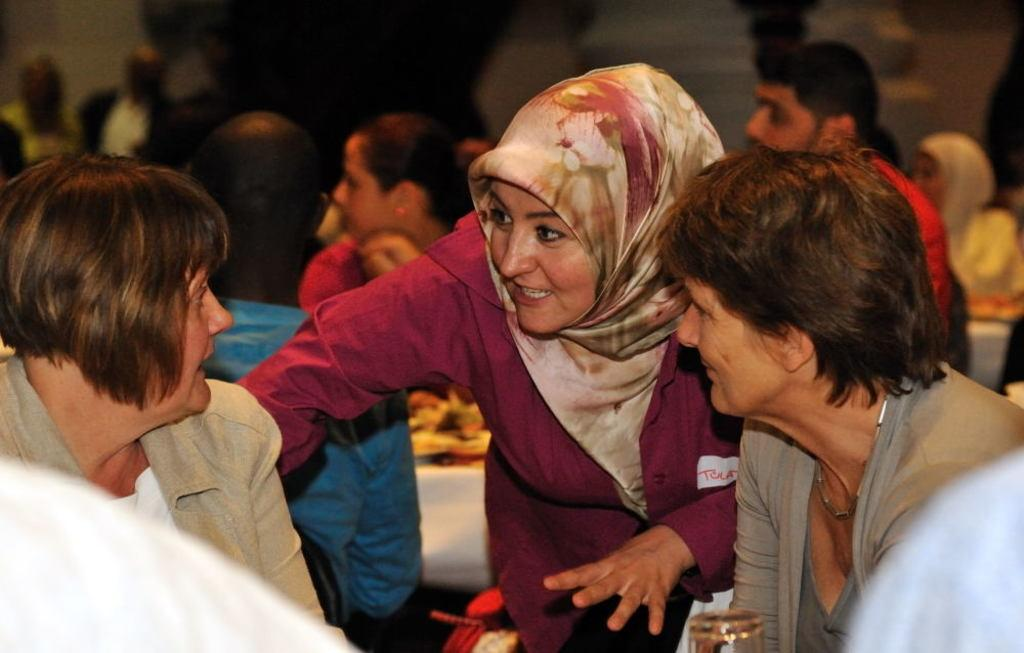How many people are in the image? The number of people in the image is not specified, but there are people present. What can be observed about the background of the image? The background of the image is dark. Can you see any bones in the image? There is no mention of bones in the image, so it cannot be determined if any are present. Is there any quicksand visible in the image? There is no mention of quicksand in the image, so it cannot be determined if any is present. Where is the faucet located in the image? There is no mention of a faucet in the image, so it cannot be determined if one is present. 